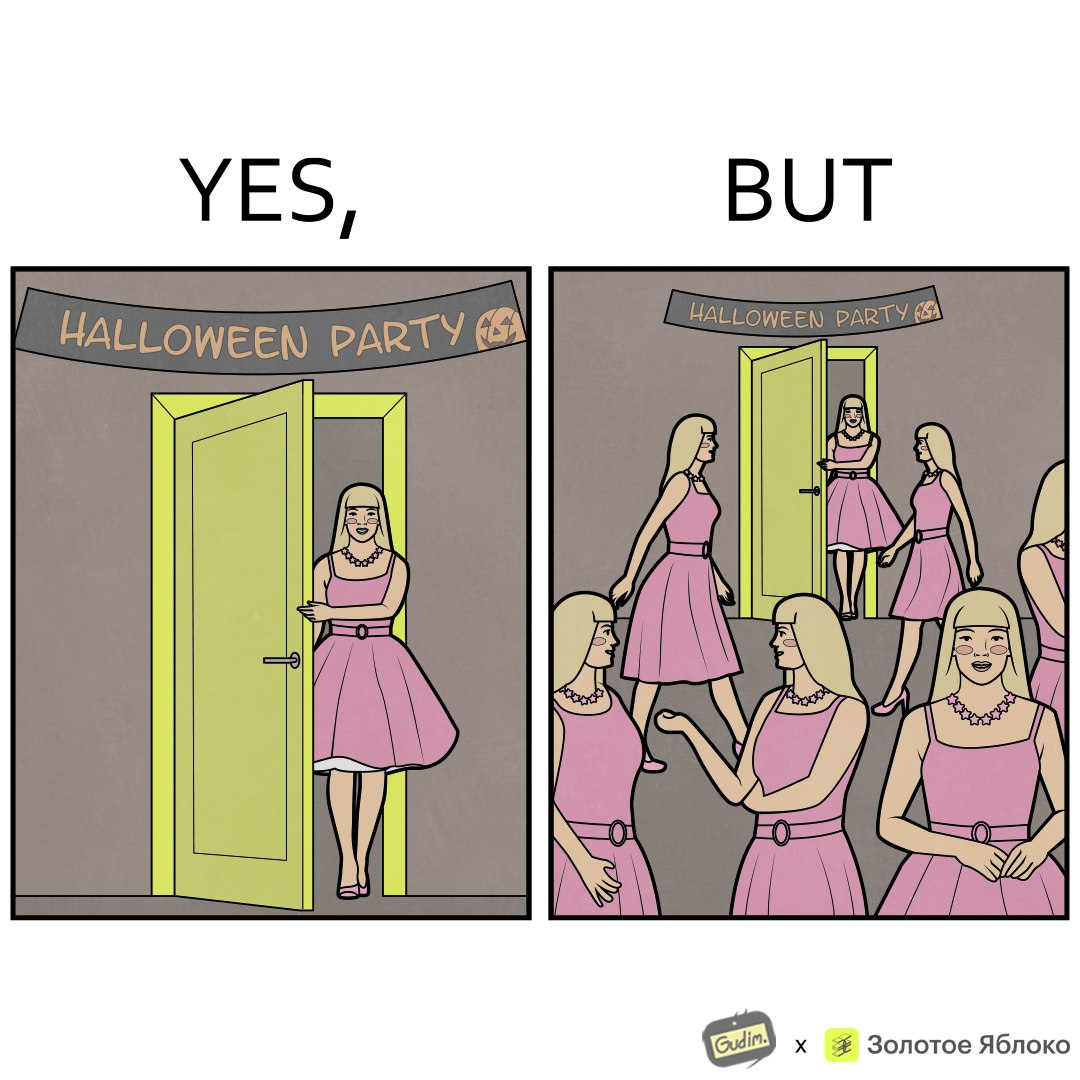What is shown in this image? The image is funny, as the person entering the Halloween Party has a costume that is identical to many other people in the party. 